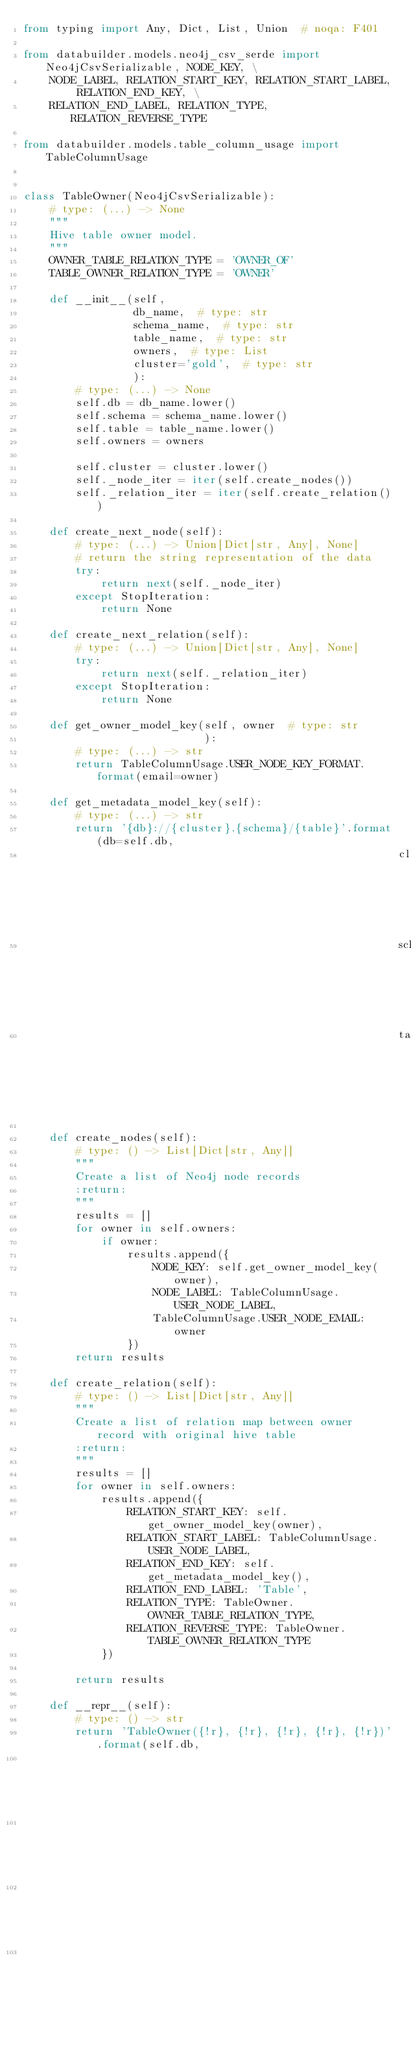<code> <loc_0><loc_0><loc_500><loc_500><_Python_>from typing import Any, Dict, List, Union  # noqa: F401

from databuilder.models.neo4j_csv_serde import Neo4jCsvSerializable, NODE_KEY, \
    NODE_LABEL, RELATION_START_KEY, RELATION_START_LABEL, RELATION_END_KEY, \
    RELATION_END_LABEL, RELATION_TYPE, RELATION_REVERSE_TYPE

from databuilder.models.table_column_usage import TableColumnUsage


class TableOwner(Neo4jCsvSerializable):
    # type: (...) -> None
    """
    Hive table owner model.
    """
    OWNER_TABLE_RELATION_TYPE = 'OWNER_OF'
    TABLE_OWNER_RELATION_TYPE = 'OWNER'

    def __init__(self,
                 db_name,  # type: str
                 schema_name,  # type: str
                 table_name,  # type: str
                 owners,  # type: List
                 cluster='gold',  # type: str
                 ):
        # type: (...) -> None
        self.db = db_name.lower()
        self.schema = schema_name.lower()
        self.table = table_name.lower()
        self.owners = owners

        self.cluster = cluster.lower()
        self._node_iter = iter(self.create_nodes())
        self._relation_iter = iter(self.create_relation())

    def create_next_node(self):
        # type: (...) -> Union[Dict[str, Any], None]
        # return the string representation of the data
        try:
            return next(self._node_iter)
        except StopIteration:
            return None

    def create_next_relation(self):
        # type: (...) -> Union[Dict[str, Any], None]
        try:
            return next(self._relation_iter)
        except StopIteration:
            return None

    def get_owner_model_key(self, owner  # type: str
                            ):
        # type: (...) -> str
        return TableColumnUsage.USER_NODE_KEY_FORMAT.format(email=owner)

    def get_metadata_model_key(self):
        # type: (...) -> str
        return '{db}://{cluster}.{schema}/{table}'.format(db=self.db,
                                                          cluster=self.cluster,
                                                          schema=self.schema,
                                                          table=self.table)

    def create_nodes(self):
        # type: () -> List[Dict[str, Any]]
        """
        Create a list of Neo4j node records
        :return:
        """
        results = []
        for owner in self.owners:
            if owner:
                results.append({
                    NODE_KEY: self.get_owner_model_key(owner),
                    NODE_LABEL: TableColumnUsage.USER_NODE_LABEL,
                    TableColumnUsage.USER_NODE_EMAIL: owner
                })
        return results

    def create_relation(self):
        # type: () -> List[Dict[str, Any]]
        """
        Create a list of relation map between owner record with original hive table
        :return:
        """
        results = []
        for owner in self.owners:
            results.append({
                RELATION_START_KEY: self.get_owner_model_key(owner),
                RELATION_START_LABEL: TableColumnUsage.USER_NODE_LABEL,
                RELATION_END_KEY: self.get_metadata_model_key(),
                RELATION_END_LABEL: 'Table',
                RELATION_TYPE: TableOwner.OWNER_TABLE_RELATION_TYPE,
                RELATION_REVERSE_TYPE: TableOwner.TABLE_OWNER_RELATION_TYPE
            })

        return results

    def __repr__(self):
        # type: () -> str
        return 'TableOwner({!r}, {!r}, {!r}, {!r}, {!r})'.format(self.db,
                                                                 self.cluster,
                                                                 self.schema,
                                                                 self.table,
                                                                 self.owners)
</code> 